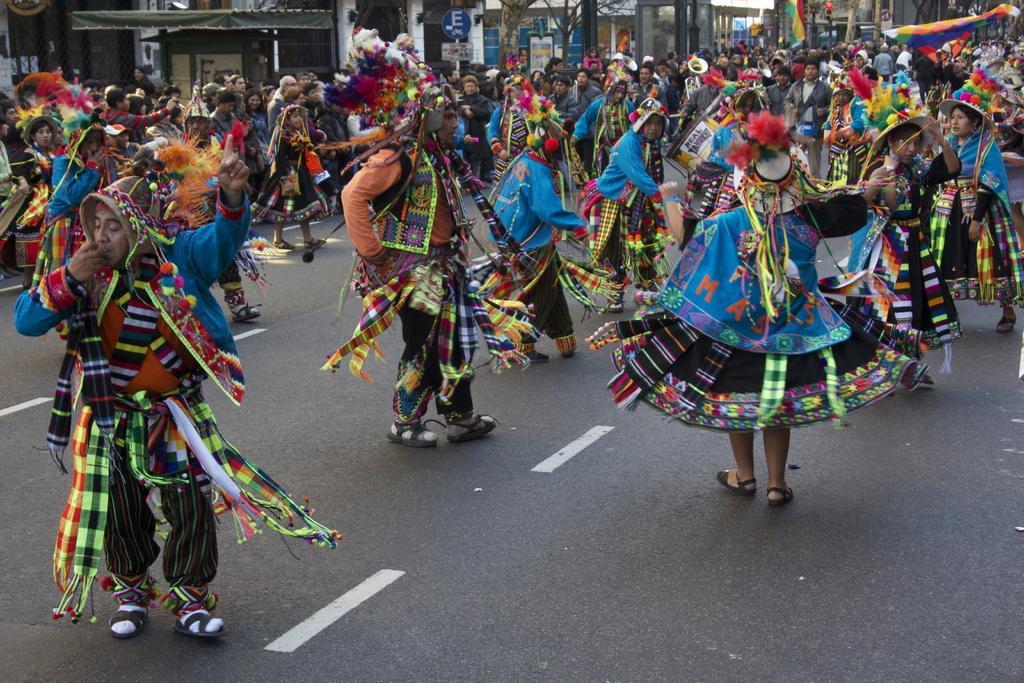Could you give a brief overview of what you see in this image? In this image there are tribes dancing on the road. The people watching at them at back side. There are trees and buildings. 